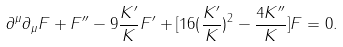<formula> <loc_0><loc_0><loc_500><loc_500>\partial ^ { \mu } \partial _ { \mu } F + F ^ { \prime \prime } - 9 \frac { K ^ { \prime } } { K } F ^ { \prime } + [ 1 6 ( \frac { K ^ { \prime } } { K } ) ^ { 2 } - \frac { 4 K ^ { \prime \prime } } { K } ] F = 0 .</formula> 